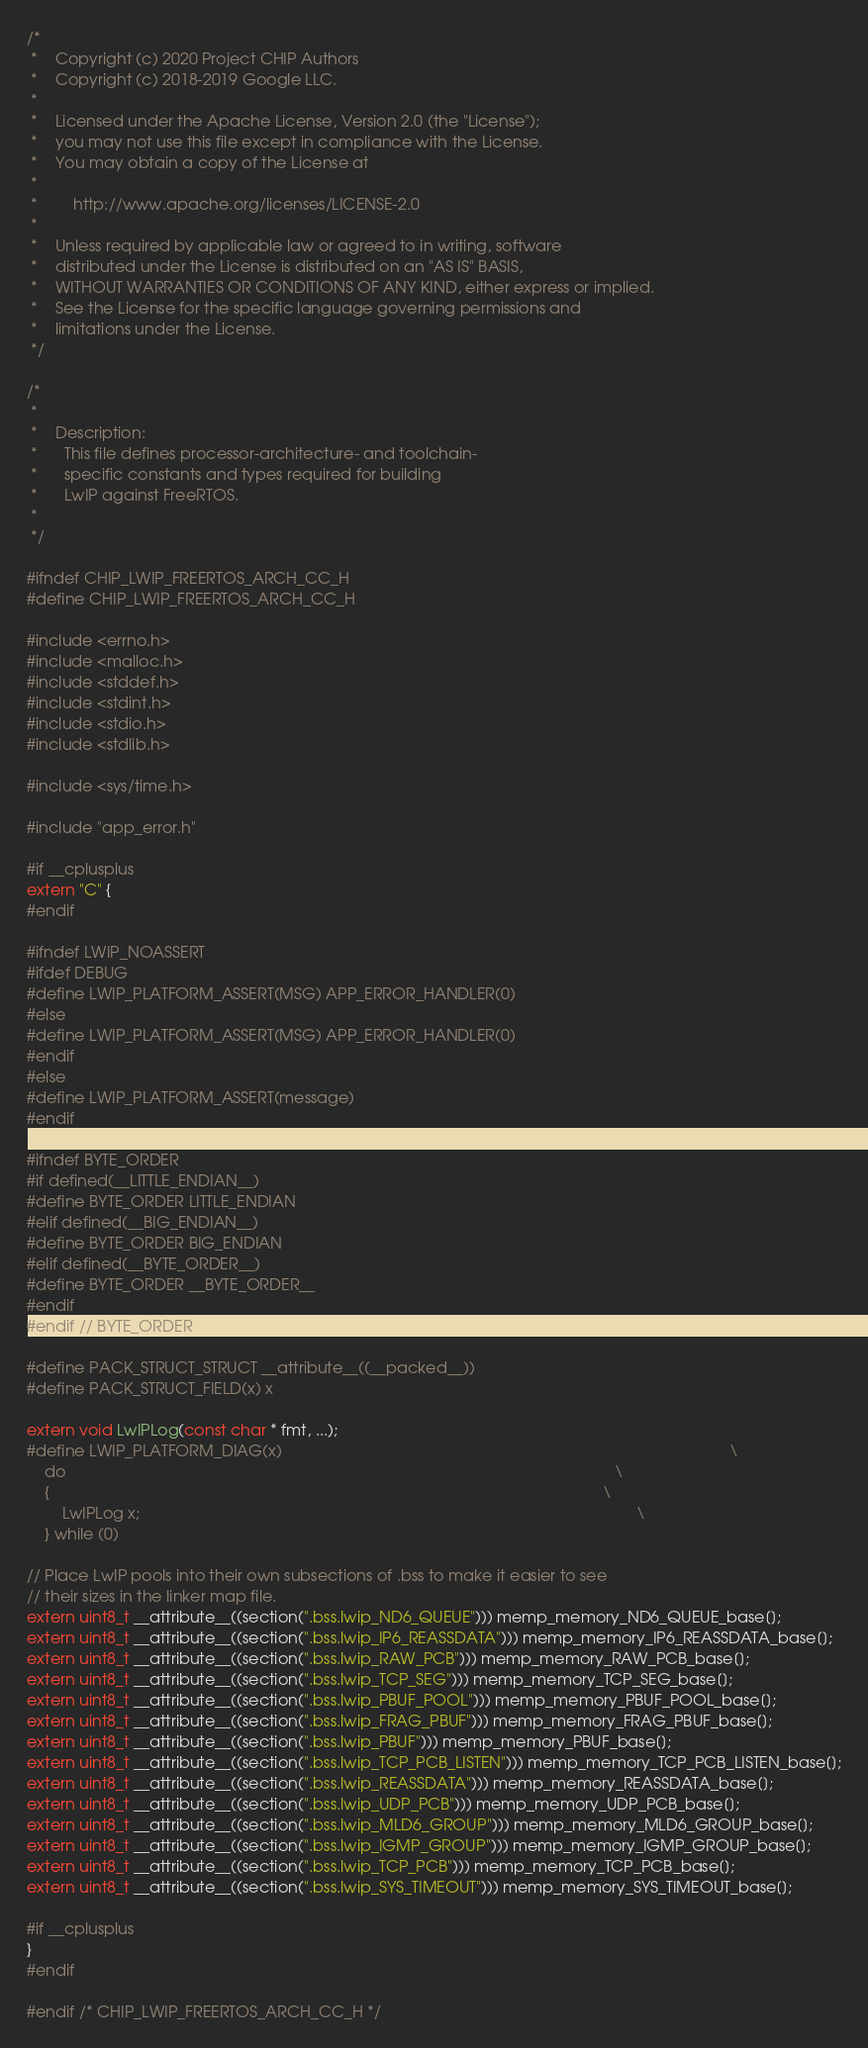<code> <loc_0><loc_0><loc_500><loc_500><_C_>/*
 *    Copyright (c) 2020 Project CHIP Authors
 *    Copyright (c) 2018-2019 Google LLC.
 *
 *    Licensed under the Apache License, Version 2.0 (the "License");
 *    you may not use this file except in compliance with the License.
 *    You may obtain a copy of the License at
 *
 *        http://www.apache.org/licenses/LICENSE-2.0
 *
 *    Unless required by applicable law or agreed to in writing, software
 *    distributed under the License is distributed on an "AS IS" BASIS,
 *    WITHOUT WARRANTIES OR CONDITIONS OF ANY KIND, either express or implied.
 *    See the License for the specific language governing permissions and
 *    limitations under the License.
 */

/*
 *
 *    Description:
 *      This file defines processor-architecture- and toolchain-
 *      specific constants and types required for building
 *      LwIP against FreeRTOS.
 *
 */

#ifndef CHIP_LWIP_FREERTOS_ARCH_CC_H
#define CHIP_LWIP_FREERTOS_ARCH_CC_H

#include <errno.h>
#include <malloc.h>
#include <stddef.h>
#include <stdint.h>
#include <stdio.h>
#include <stdlib.h>

#include <sys/time.h>

#include "app_error.h"

#if __cplusplus
extern "C" {
#endif

#ifndef LWIP_NOASSERT
#ifdef DEBUG
#define LWIP_PLATFORM_ASSERT(MSG) APP_ERROR_HANDLER(0)
#else
#define LWIP_PLATFORM_ASSERT(MSG) APP_ERROR_HANDLER(0)
#endif
#else
#define LWIP_PLATFORM_ASSERT(message)
#endif

#ifndef BYTE_ORDER
#if defined(__LITTLE_ENDIAN__)
#define BYTE_ORDER LITTLE_ENDIAN
#elif defined(__BIG_ENDIAN__)
#define BYTE_ORDER BIG_ENDIAN
#elif defined(__BYTE_ORDER__)
#define BYTE_ORDER __BYTE_ORDER__
#endif
#endif // BYTE_ORDER

#define PACK_STRUCT_STRUCT __attribute__((__packed__))
#define PACK_STRUCT_FIELD(x) x

extern void LwIPLog(const char * fmt, ...);
#define LWIP_PLATFORM_DIAG(x)                                                                                                      \
    do                                                                                                                             \
    {                                                                                                                              \
        LwIPLog x;                                                                                                                 \
    } while (0)

// Place LwIP pools into their own subsections of .bss to make it easier to see
// their sizes in the linker map file.
extern uint8_t __attribute__((section(".bss.lwip_ND6_QUEUE"))) memp_memory_ND6_QUEUE_base[];
extern uint8_t __attribute__((section(".bss.lwip_IP6_REASSDATA"))) memp_memory_IP6_REASSDATA_base[];
extern uint8_t __attribute__((section(".bss.lwip_RAW_PCB"))) memp_memory_RAW_PCB_base[];
extern uint8_t __attribute__((section(".bss.lwip_TCP_SEG"))) memp_memory_TCP_SEG_base[];
extern uint8_t __attribute__((section(".bss.lwip_PBUF_POOL"))) memp_memory_PBUF_POOL_base[];
extern uint8_t __attribute__((section(".bss.lwip_FRAG_PBUF"))) memp_memory_FRAG_PBUF_base[];
extern uint8_t __attribute__((section(".bss.lwip_PBUF"))) memp_memory_PBUF_base[];
extern uint8_t __attribute__((section(".bss.lwip_TCP_PCB_LISTEN"))) memp_memory_TCP_PCB_LISTEN_base[];
extern uint8_t __attribute__((section(".bss.lwip_REASSDATA"))) memp_memory_REASSDATA_base[];
extern uint8_t __attribute__((section(".bss.lwip_UDP_PCB"))) memp_memory_UDP_PCB_base[];
extern uint8_t __attribute__((section(".bss.lwip_MLD6_GROUP"))) memp_memory_MLD6_GROUP_base[];
extern uint8_t __attribute__((section(".bss.lwip_IGMP_GROUP"))) memp_memory_IGMP_GROUP_base[];
extern uint8_t __attribute__((section(".bss.lwip_TCP_PCB"))) memp_memory_TCP_PCB_base[];
extern uint8_t __attribute__((section(".bss.lwip_SYS_TIMEOUT"))) memp_memory_SYS_TIMEOUT_base[];

#if __cplusplus
}
#endif

#endif /* CHIP_LWIP_FREERTOS_ARCH_CC_H */
</code> 